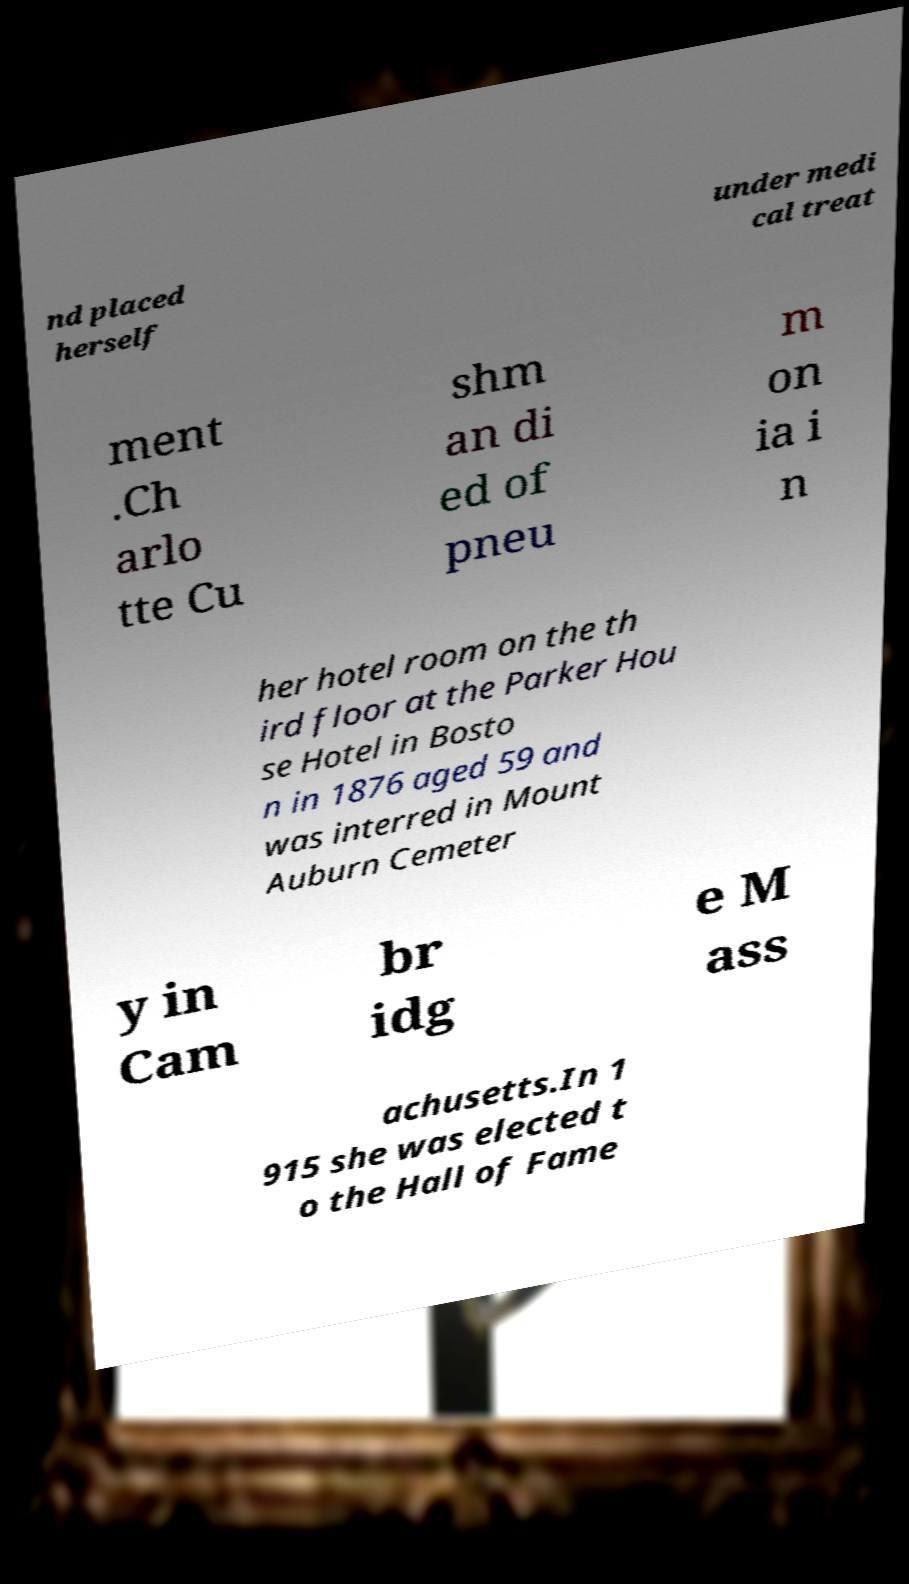Please read and relay the text visible in this image. What does it say? nd placed herself under medi cal treat ment .Ch arlo tte Cu shm an di ed of pneu m on ia i n her hotel room on the th ird floor at the Parker Hou se Hotel in Bosto n in 1876 aged 59 and was interred in Mount Auburn Cemeter y in Cam br idg e M ass achusetts.In 1 915 she was elected t o the Hall of Fame 